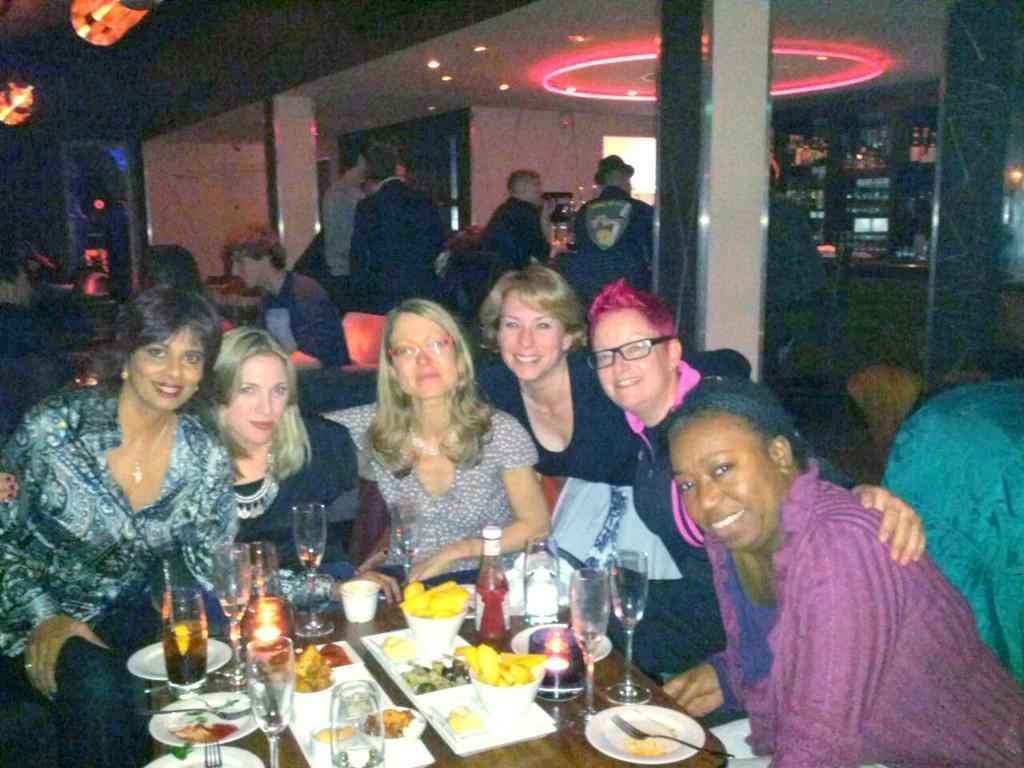In one or two sentences, can you explain what this image depicts? At the bottom of the image there is a table with glasses, plates, forks, bowls with food items and there are some other things. Behind the table there are a few people sitting. Behind them there are a few people standing and also there are poles. There is a table. Behind the table there is a cupboard with bottles. At the top of the image there is ceiling with lights. And there is a blur background. 